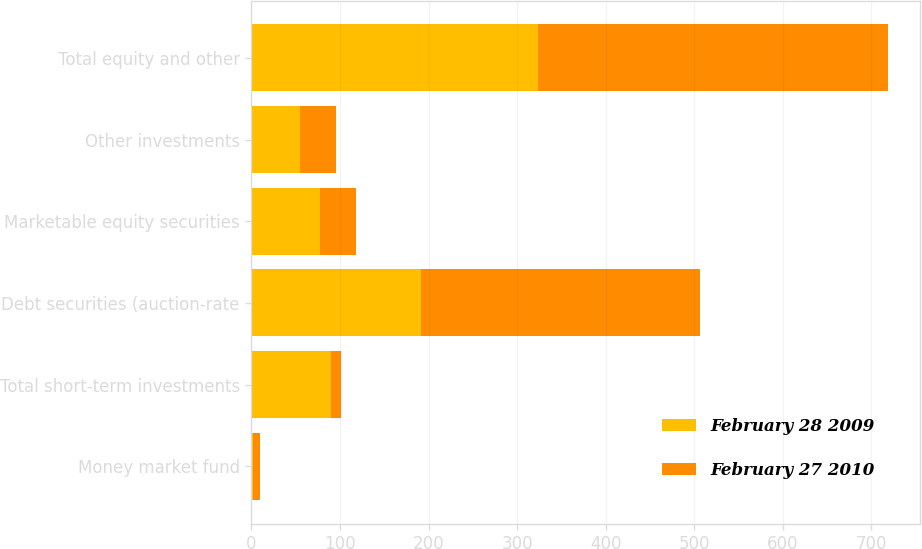Convert chart. <chart><loc_0><loc_0><loc_500><loc_500><stacked_bar_chart><ecel><fcel>Money market fund<fcel>Total short-term investments<fcel>Debt securities (auction-rate<fcel>Marketable equity securities<fcel>Other investments<fcel>Total equity and other<nl><fcel>February 28 2009<fcel>2<fcel>90<fcel>192<fcel>77<fcel>55<fcel>324<nl><fcel>February 27 2010<fcel>8<fcel>11<fcel>314<fcel>41<fcel>40<fcel>395<nl></chart> 